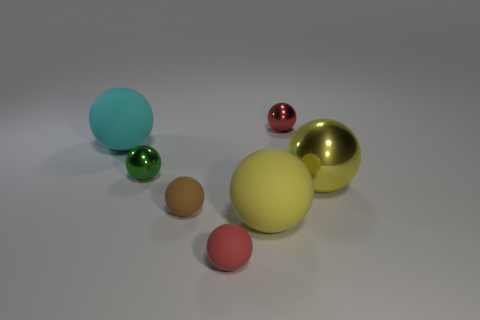Subtract all green spheres. How many spheres are left? 6 Subtract all tiny red matte balls. How many balls are left? 6 Subtract all green spheres. Subtract all yellow cubes. How many spheres are left? 6 Add 1 red spheres. How many objects exist? 8 Subtract all rubber objects. Subtract all yellow spheres. How many objects are left? 1 Add 6 green metal things. How many green metal things are left? 7 Add 6 tiny green things. How many tiny green things exist? 7 Subtract 0 purple spheres. How many objects are left? 7 